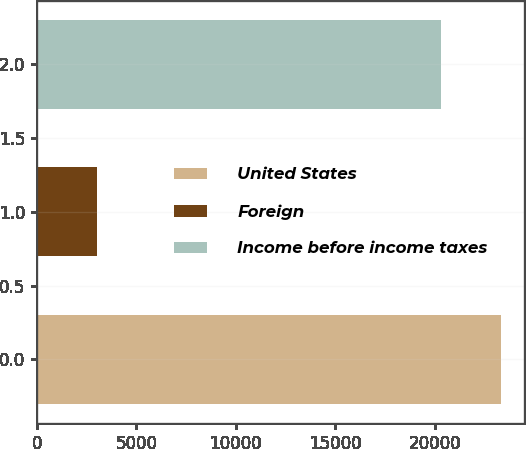<chart> <loc_0><loc_0><loc_500><loc_500><bar_chart><fcel>United States<fcel>Foreign<fcel>Income before income taxes<nl><fcel>23309<fcel>3004<fcel>20305<nl></chart> 